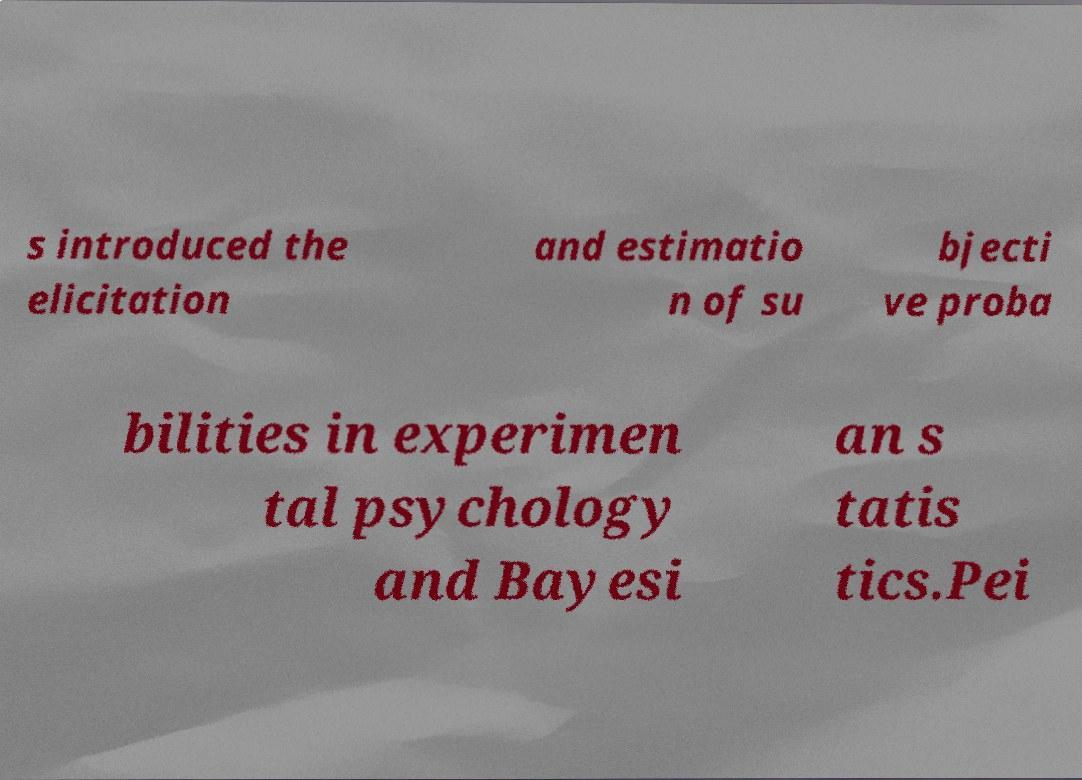I need the written content from this picture converted into text. Can you do that? s introduced the elicitation and estimatio n of su bjecti ve proba bilities in experimen tal psychology and Bayesi an s tatis tics.Pei 